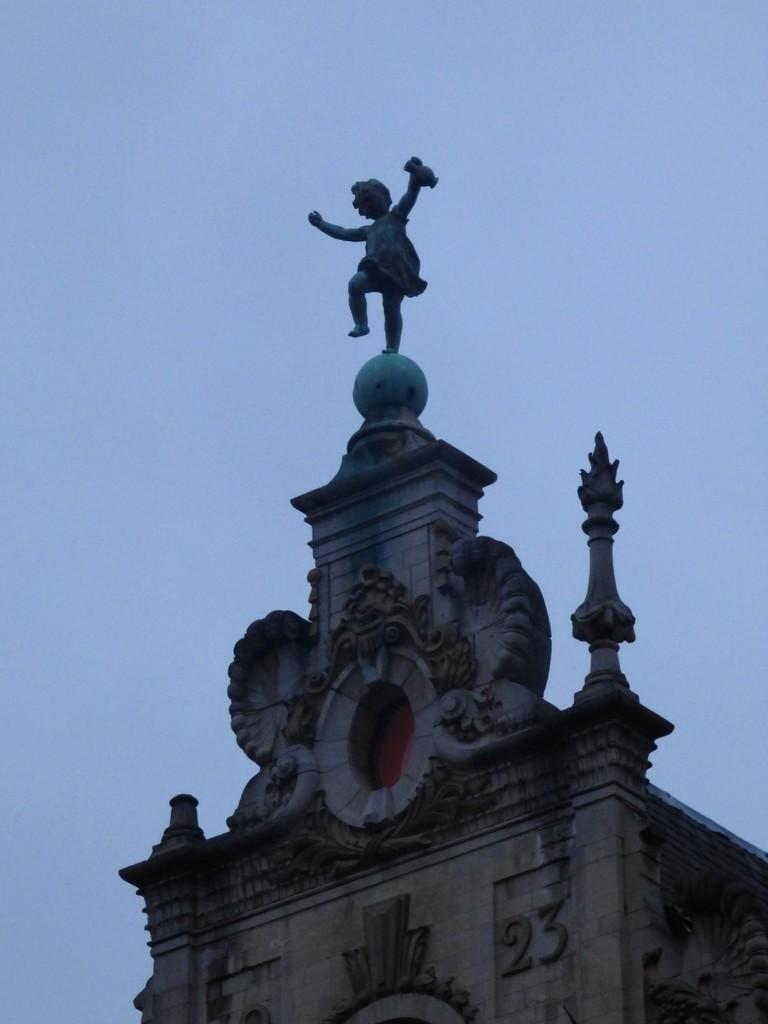What type of structure is present in the image? There is a building in the image. Is there any additional feature on the building? Yes, there is a statue of a person on the building. What can be seen in the background of the image? The sky is visible in the background of the image. How many chairs are placed around the potato in the image? There are no chairs or potatoes present in the image. 